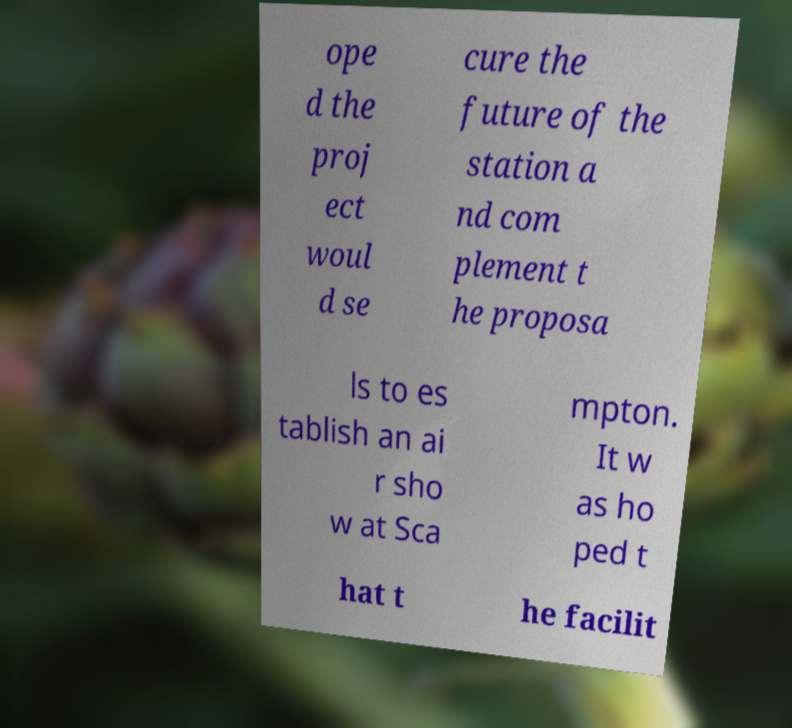Please identify and transcribe the text found in this image. ope d the proj ect woul d se cure the future of the station a nd com plement t he proposa ls to es tablish an ai r sho w at Sca mpton. It w as ho ped t hat t he facilit 